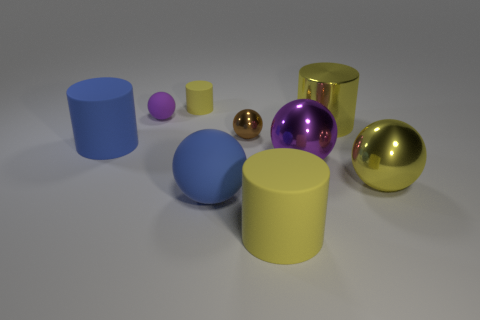Can you explain the differences in textures among the objects in the image? Certainly! In the image, there's a variety of textures. The spheres and cylinders exhibit different finishes: the golden and large purple objects have reflective surfaces indicative of metallic textures, while the blue, yellow, and small purple objects have matte finishes, which could suggest plastic or painted materials. These contrasting textures offer insights into the objects' potential material composition. 